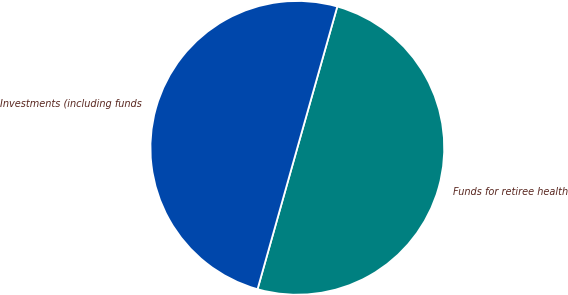<chart> <loc_0><loc_0><loc_500><loc_500><pie_chart><fcel>Funds for retiree health<fcel>Investments (including funds<nl><fcel>49.98%<fcel>50.02%<nl></chart> 